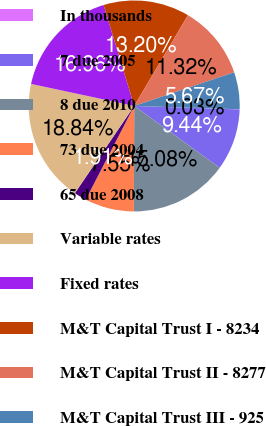Convert chart. <chart><loc_0><loc_0><loc_500><loc_500><pie_chart><fcel>In thousands<fcel>7 due 2005<fcel>8 due 2010<fcel>73 due 2004<fcel>65 due 2008<fcel>Variable rates<fcel>Fixed rates<fcel>M&T Capital Trust I - 8234<fcel>M&T Capital Trust II - 8277<fcel>M&T Capital Trust III - 925<nl><fcel>0.03%<fcel>9.44%<fcel>15.08%<fcel>7.55%<fcel>1.91%<fcel>18.84%<fcel>16.96%<fcel>13.2%<fcel>11.32%<fcel>5.67%<nl></chart> 